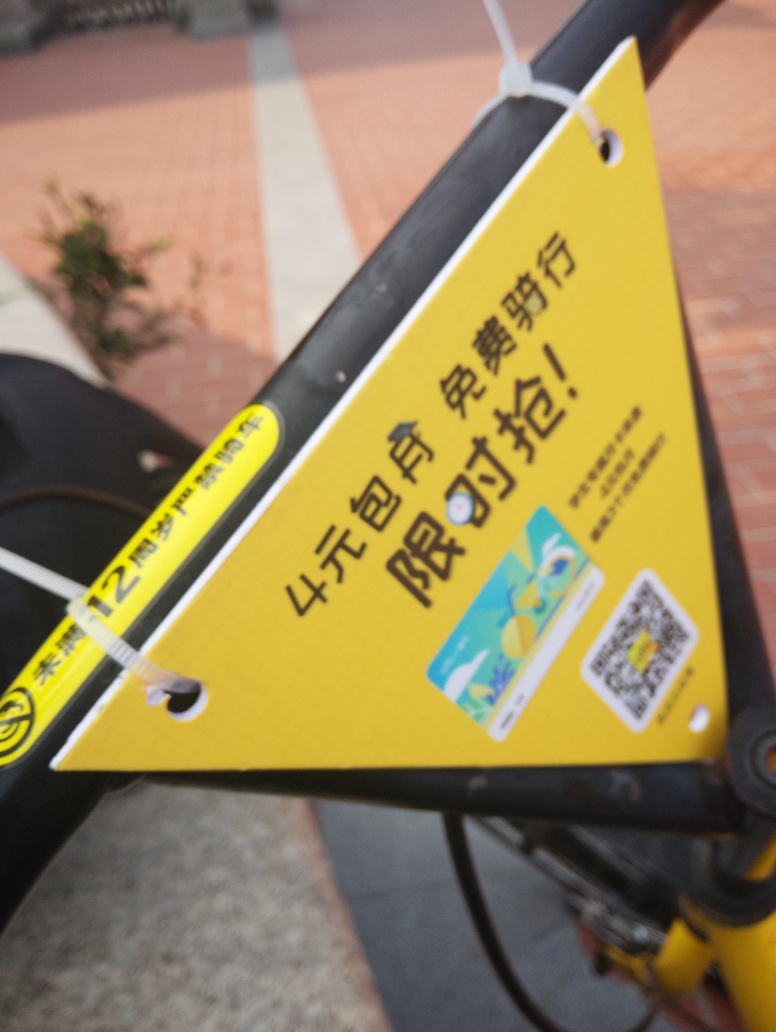Is there any loss of texture details in the image?
A. No
B. Yes
Answer with the option's letter from the given choices directly.
 B. 